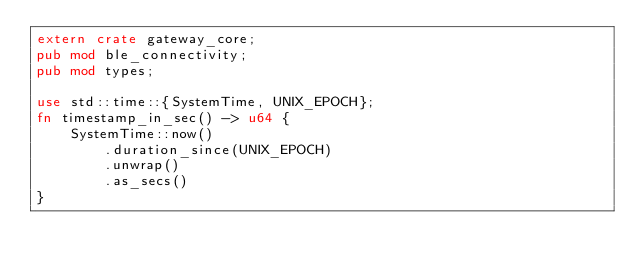<code> <loc_0><loc_0><loc_500><loc_500><_Rust_>extern crate gateway_core;
pub mod ble_connectivity;
pub mod types;

use std::time::{SystemTime, UNIX_EPOCH};
fn timestamp_in_sec() -> u64 {
    SystemTime::now()
        .duration_since(UNIX_EPOCH)
        .unwrap()
        .as_secs()
}
</code> 